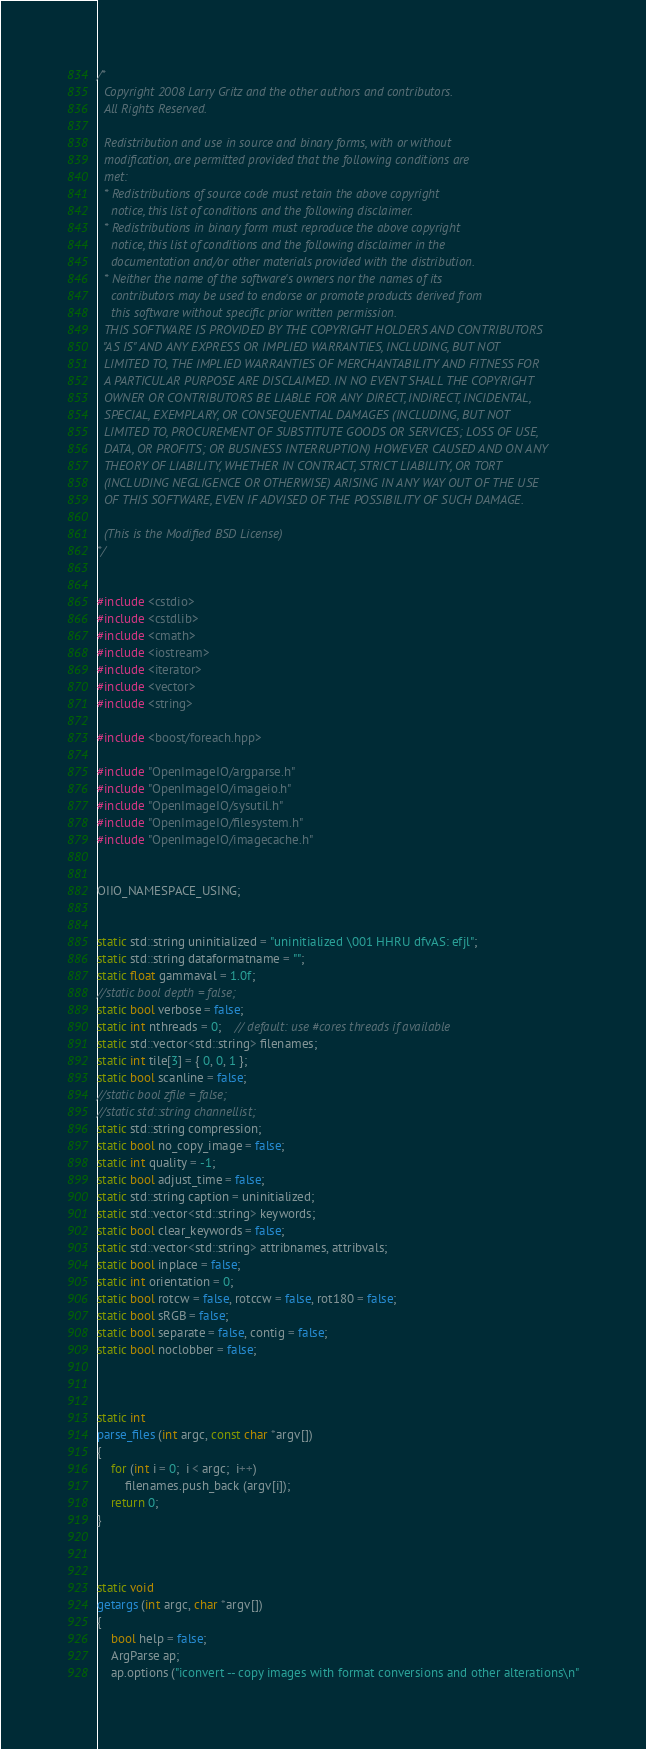<code> <loc_0><loc_0><loc_500><loc_500><_C++_>/*
  Copyright 2008 Larry Gritz and the other authors and contributors.
  All Rights Reserved.

  Redistribution and use in source and binary forms, with or without
  modification, are permitted provided that the following conditions are
  met:
  * Redistributions of source code must retain the above copyright
    notice, this list of conditions and the following disclaimer.
  * Redistributions in binary form must reproduce the above copyright
    notice, this list of conditions and the following disclaimer in the
    documentation and/or other materials provided with the distribution.
  * Neither the name of the software's owners nor the names of its
    contributors may be used to endorse or promote products derived from
    this software without specific prior written permission.
  THIS SOFTWARE IS PROVIDED BY THE COPYRIGHT HOLDERS AND CONTRIBUTORS
  "AS IS" AND ANY EXPRESS OR IMPLIED WARRANTIES, INCLUDING, BUT NOT
  LIMITED TO, THE IMPLIED WARRANTIES OF MERCHANTABILITY AND FITNESS FOR
  A PARTICULAR PURPOSE ARE DISCLAIMED. IN NO EVENT SHALL THE COPYRIGHT
  OWNER OR CONTRIBUTORS BE LIABLE FOR ANY DIRECT, INDIRECT, INCIDENTAL,
  SPECIAL, EXEMPLARY, OR CONSEQUENTIAL DAMAGES (INCLUDING, BUT NOT
  LIMITED TO, PROCUREMENT OF SUBSTITUTE GOODS OR SERVICES; LOSS OF USE,
  DATA, OR PROFITS; OR BUSINESS INTERRUPTION) HOWEVER CAUSED AND ON ANY
  THEORY OF LIABILITY, WHETHER IN CONTRACT, STRICT LIABILITY, OR TORT
  (INCLUDING NEGLIGENCE OR OTHERWISE) ARISING IN ANY WAY OUT OF THE USE
  OF THIS SOFTWARE, EVEN IF ADVISED OF THE POSSIBILITY OF SUCH DAMAGE.

  (This is the Modified BSD License)
*/


#include <cstdio>
#include <cstdlib>
#include <cmath>
#include <iostream>
#include <iterator>
#include <vector>
#include <string>

#include <boost/foreach.hpp>

#include "OpenImageIO/argparse.h"
#include "OpenImageIO/imageio.h"
#include "OpenImageIO/sysutil.h"
#include "OpenImageIO/filesystem.h"
#include "OpenImageIO/imagecache.h"


OIIO_NAMESPACE_USING;


static std::string uninitialized = "uninitialized \001 HHRU dfvAS: efjl";
static std::string dataformatname = "";
static float gammaval = 1.0f;
//static bool depth = false;
static bool verbose = false;
static int nthreads = 0;    // default: use #cores threads if available
static std::vector<std::string> filenames;
static int tile[3] = { 0, 0, 1 };
static bool scanline = false;
//static bool zfile = false;
//static std::string channellist;
static std::string compression;
static bool no_copy_image = false;
static int quality = -1;
static bool adjust_time = false;
static std::string caption = uninitialized;
static std::vector<std::string> keywords;
static bool clear_keywords = false;
static std::vector<std::string> attribnames, attribvals;
static bool inplace = false;
static int orientation = 0;
static bool rotcw = false, rotccw = false, rot180 = false;
static bool sRGB = false;
static bool separate = false, contig = false;
static bool noclobber = false;



static int
parse_files (int argc, const char *argv[])
{
    for (int i = 0;  i < argc;  i++)
        filenames.push_back (argv[i]);
    return 0;
}



static void
getargs (int argc, char *argv[])
{
    bool help = false;
    ArgParse ap;
    ap.options ("iconvert -- copy images with format conversions and other alterations\n"</code> 